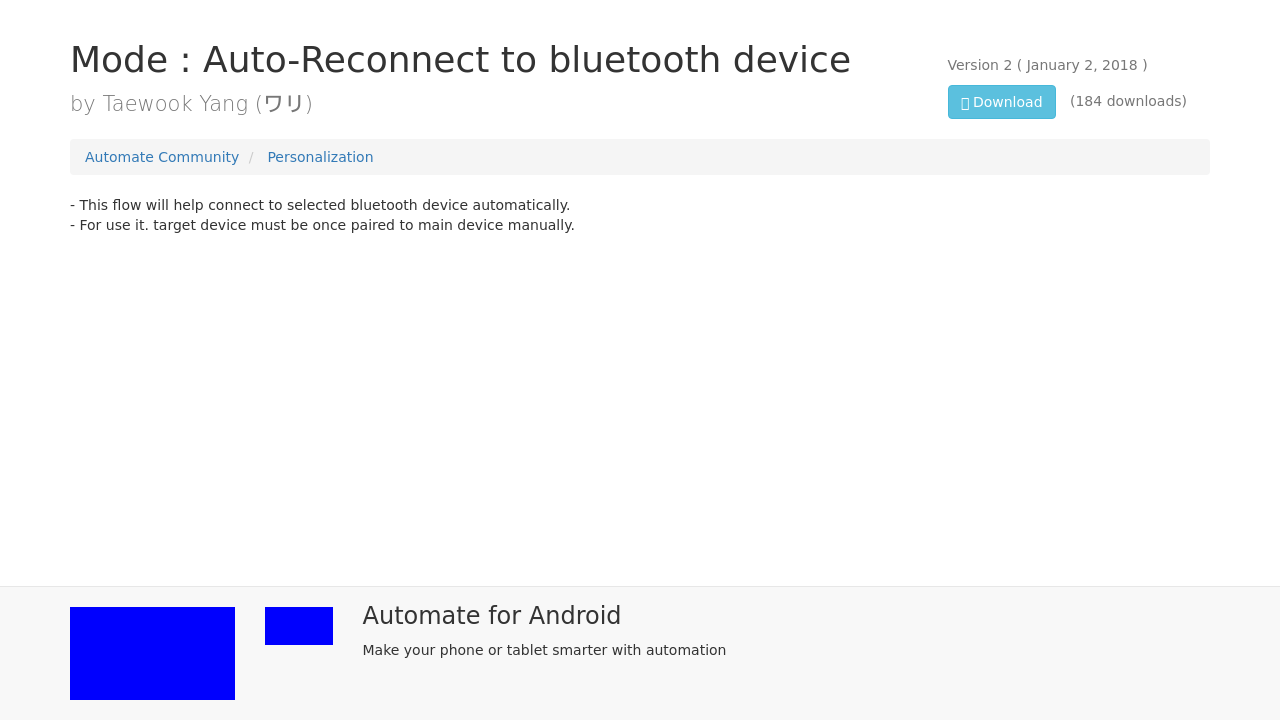Can you describe the purpose of the 'Automate Community' mentioned in the image? The 'Automate Community' appears to be a platform or a section within a website dedicated to sharing user-created flows or scripts to automate various tasks on Android devices. It is a place where users can share their own creations, download others, and discuss automation strategies. 